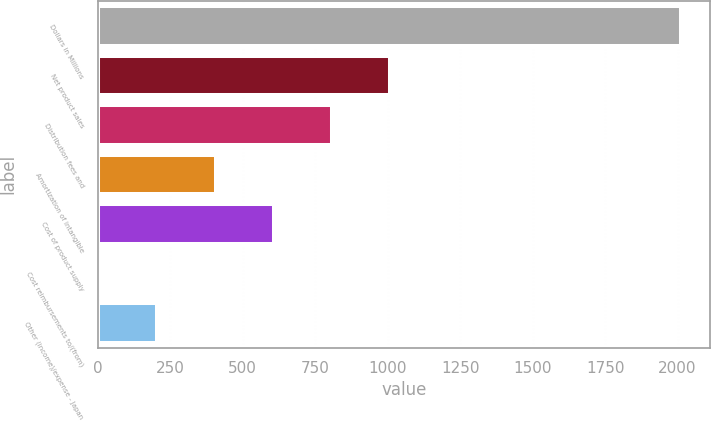<chart> <loc_0><loc_0><loc_500><loc_500><bar_chart><fcel>Dollars in Millions<fcel>Net product sales<fcel>Distribution fees and<fcel>Amortization of intangible<fcel>Cost of product supply<fcel>Cost reimbursements to/(from)<fcel>Other (income)/expense - Japan<nl><fcel>2011<fcel>1008<fcel>807.4<fcel>406.2<fcel>606.8<fcel>5<fcel>205.6<nl></chart> 